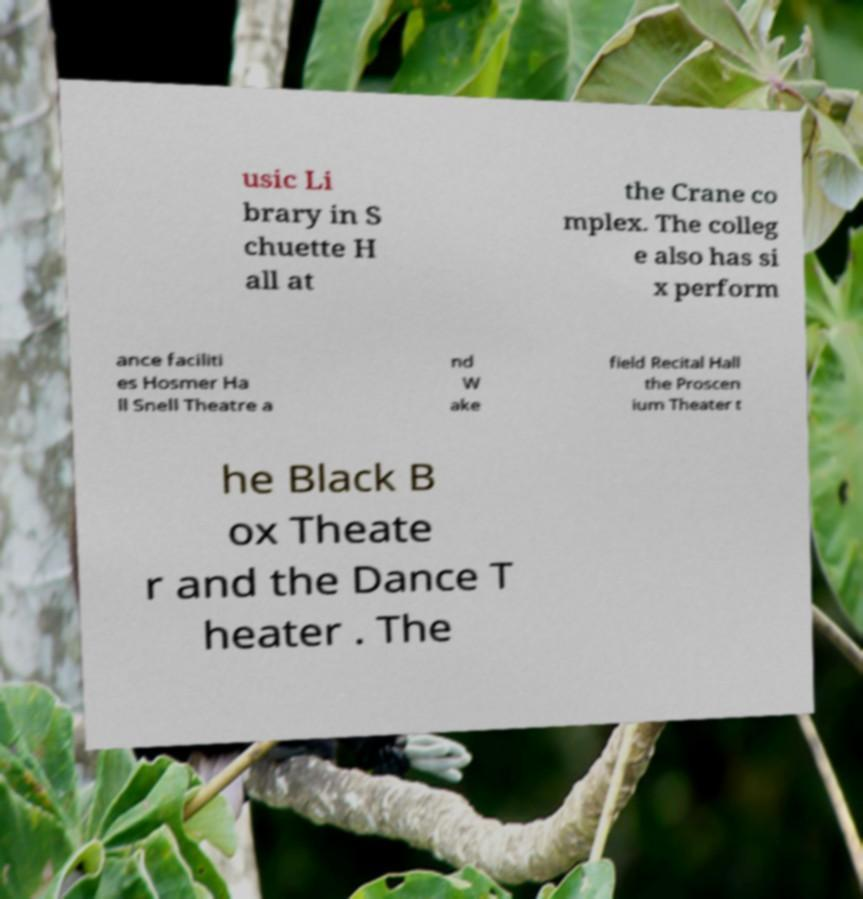I need the written content from this picture converted into text. Can you do that? usic Li brary in S chuette H all at the Crane co mplex. The colleg e also has si x perform ance faciliti es Hosmer Ha ll Snell Theatre a nd W ake field Recital Hall the Proscen ium Theater t he Black B ox Theate r and the Dance T heater . The 